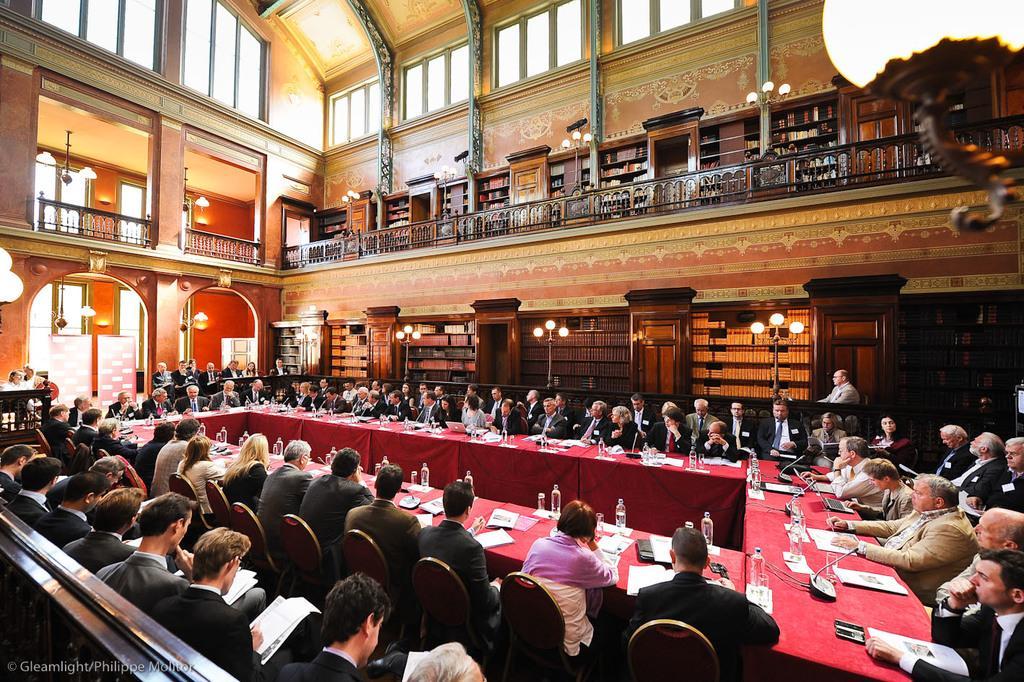In one or two sentences, can you explain what this image depicts? In this picture we can see some people sitting on chairs in front of the table, we can see some bottles, files, microphones, papers present on this table, the people on the left side are holding files, in the background there is a wall, we can see some lights here. 